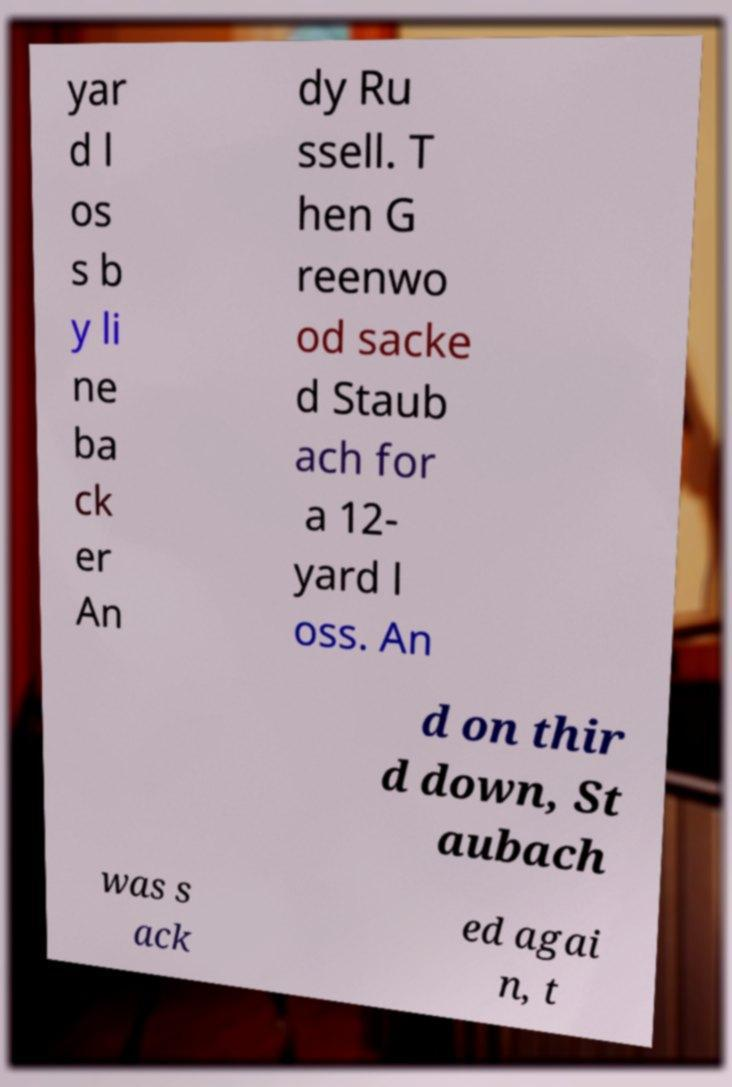Please read and relay the text visible in this image. What does it say? yar d l os s b y li ne ba ck er An dy Ru ssell. T hen G reenwo od sacke d Staub ach for a 12- yard l oss. An d on thir d down, St aubach was s ack ed agai n, t 